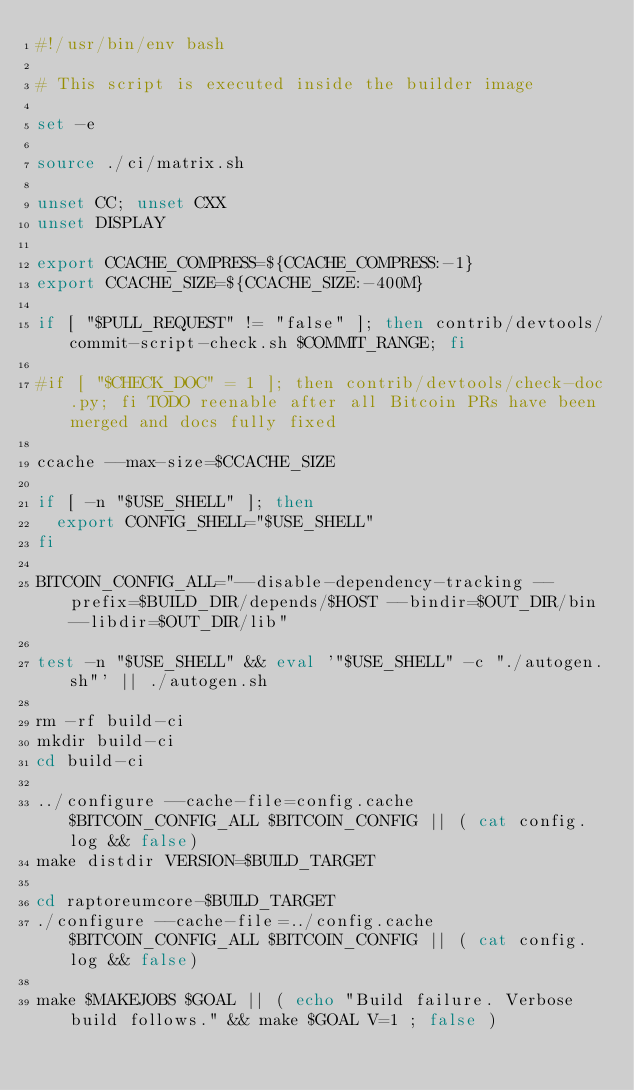<code> <loc_0><loc_0><loc_500><loc_500><_Bash_>#!/usr/bin/env bash

# This script is executed inside the builder image

set -e

source ./ci/matrix.sh

unset CC; unset CXX
unset DISPLAY

export CCACHE_COMPRESS=${CCACHE_COMPRESS:-1}
export CCACHE_SIZE=${CCACHE_SIZE:-400M}

if [ "$PULL_REQUEST" != "false" ]; then contrib/devtools/commit-script-check.sh $COMMIT_RANGE; fi

#if [ "$CHECK_DOC" = 1 ]; then contrib/devtools/check-doc.py; fi TODO reenable after all Bitcoin PRs have been merged and docs fully fixed

ccache --max-size=$CCACHE_SIZE

if [ -n "$USE_SHELL" ]; then
  export CONFIG_SHELL="$USE_SHELL"
fi

BITCOIN_CONFIG_ALL="--disable-dependency-tracking --prefix=$BUILD_DIR/depends/$HOST --bindir=$OUT_DIR/bin --libdir=$OUT_DIR/lib"

test -n "$USE_SHELL" && eval '"$USE_SHELL" -c "./autogen.sh"' || ./autogen.sh

rm -rf build-ci
mkdir build-ci
cd build-ci

../configure --cache-file=config.cache $BITCOIN_CONFIG_ALL $BITCOIN_CONFIG || ( cat config.log && false)
make distdir VERSION=$BUILD_TARGET

cd raptoreumcore-$BUILD_TARGET
./configure --cache-file=../config.cache $BITCOIN_CONFIG_ALL $BITCOIN_CONFIG || ( cat config.log && false)

make $MAKEJOBS $GOAL || ( echo "Build failure. Verbose build follows." && make $GOAL V=1 ; false )
</code> 